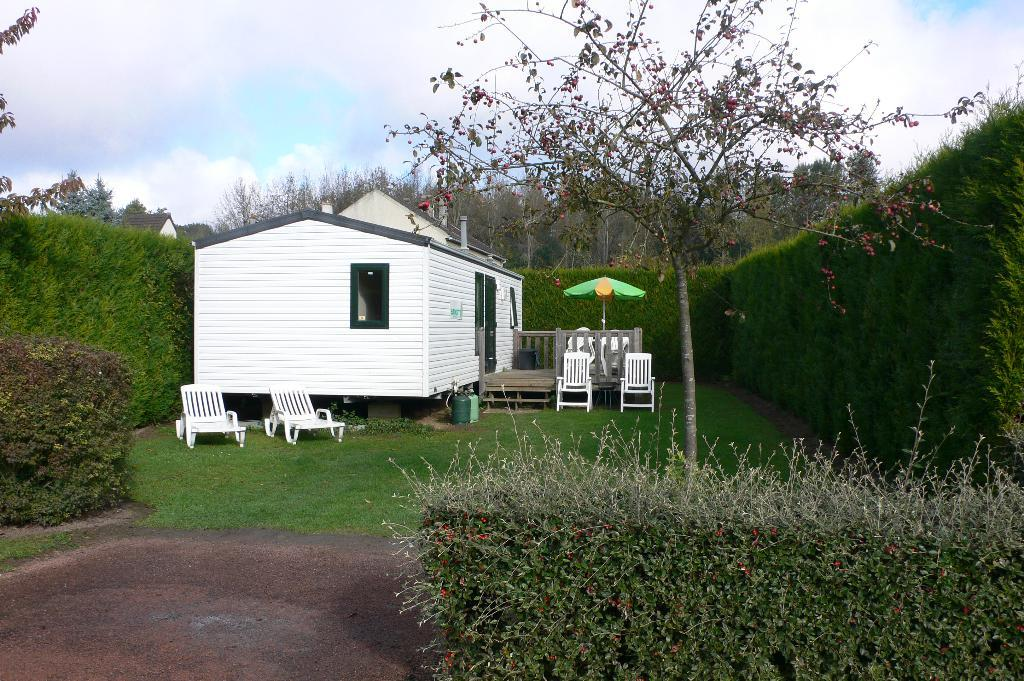What type of vegetation can be seen in the image? There is grass, plants, and trees in the image. What type of furniture is present in the image? There are chairs in the image. What objects resemble cylinders in the image? There are cylinders in the image. What type of shelter is visible in the image? There are houses in the image. What is visible in the background of the image? The sky is visible in the background of the image. What can be seen in the sky? There are clouds in the sky. What type of drink is being served under the umbrella in the image? There is no drink or umbrella present in the image. What type of yarn is being used to decorate the trees in the image? There is no yarn present in the image; the trees are natural. 